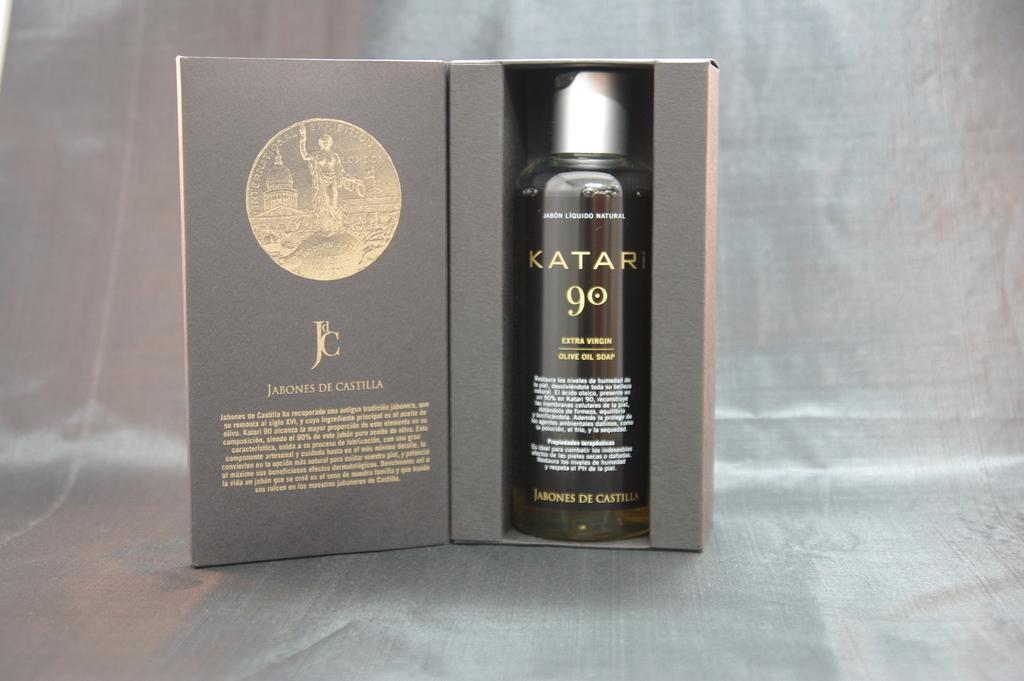Describe this image in one or two sentences. On the table there is a bottle in the box. Bottle is in black color. And we can see a card attached to it. 